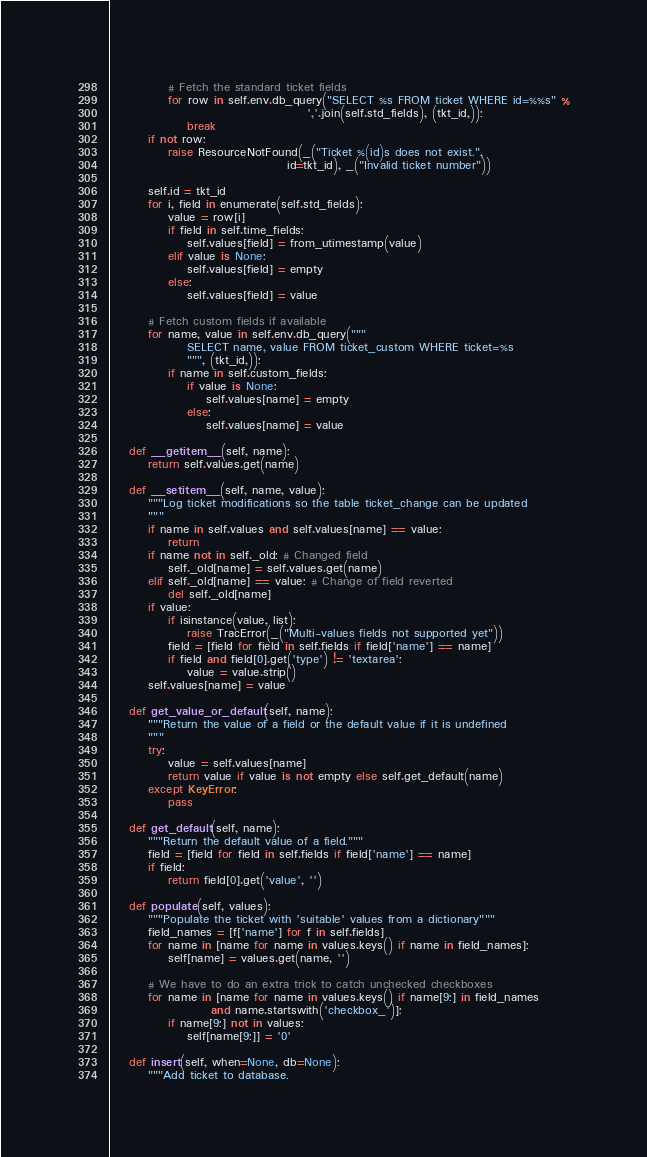Convert code to text. <code><loc_0><loc_0><loc_500><loc_500><_Python_>            # Fetch the standard ticket fields
            for row in self.env.db_query("SELECT %s FROM ticket WHERE id=%%s" %
                                         ','.join(self.std_fields), (tkt_id,)):
                break
        if not row:
            raise ResourceNotFound(_("Ticket %(id)s does not exist.", 
                                     id=tkt_id), _("Invalid ticket number"))

        self.id = tkt_id
        for i, field in enumerate(self.std_fields):
            value = row[i]
            if field in self.time_fields:
                self.values[field] = from_utimestamp(value)
            elif value is None:
                self.values[field] = empty
            else:
                self.values[field] = value

        # Fetch custom fields if available
        for name, value in self.env.db_query("""
                SELECT name, value FROM ticket_custom WHERE ticket=%s
                """, (tkt_id,)):
            if name in self.custom_fields:
                if value is None:
                    self.values[name] = empty
                else:
                    self.values[name] = value

    def __getitem__(self, name):
        return self.values.get(name)

    def __setitem__(self, name, value):
        """Log ticket modifications so the table ticket_change can be updated
        """
        if name in self.values and self.values[name] == value:
            return
        if name not in self._old: # Changed field
            self._old[name] = self.values.get(name)
        elif self._old[name] == value: # Change of field reverted
            del self._old[name]
        if value:
            if isinstance(value, list):
                raise TracError(_("Multi-values fields not supported yet"))
            field = [field for field in self.fields if field['name'] == name]
            if field and field[0].get('type') != 'textarea':
                value = value.strip()
        self.values[name] = value

    def get_value_or_default(self, name):
        """Return the value of a field or the default value if it is undefined
        """
        try:
            value = self.values[name]
            return value if value is not empty else self.get_default(name)
        except KeyError:
            pass

    def get_default(self, name):
        """Return the default value of a field."""
        field = [field for field in self.fields if field['name'] == name]
        if field:
            return field[0].get('value', '')

    def populate(self, values):
        """Populate the ticket with 'suitable' values from a dictionary"""
        field_names = [f['name'] for f in self.fields]
        for name in [name for name in values.keys() if name in field_names]:
            self[name] = values.get(name, '')

        # We have to do an extra trick to catch unchecked checkboxes
        for name in [name for name in values.keys() if name[9:] in field_names
                     and name.startswith('checkbox_')]:
            if name[9:] not in values:
                self[name[9:]] = '0'

    def insert(self, when=None, db=None):
        """Add ticket to database.
</code> 